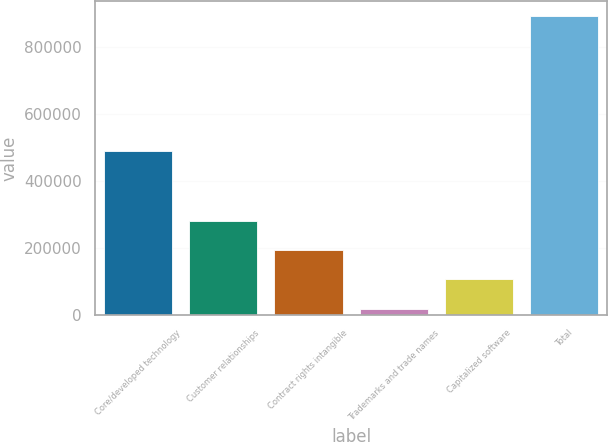Convert chart. <chart><loc_0><loc_0><loc_500><loc_500><bar_chart><fcel>Core/developed technology<fcel>Customer relationships<fcel>Contract rights intangible<fcel>Trademarks and trade names<fcel>Capitalized software<fcel>Total<nl><fcel>490242<fcel>281046<fcel>193624<fcel>18779<fcel>106201<fcel>893002<nl></chart> 